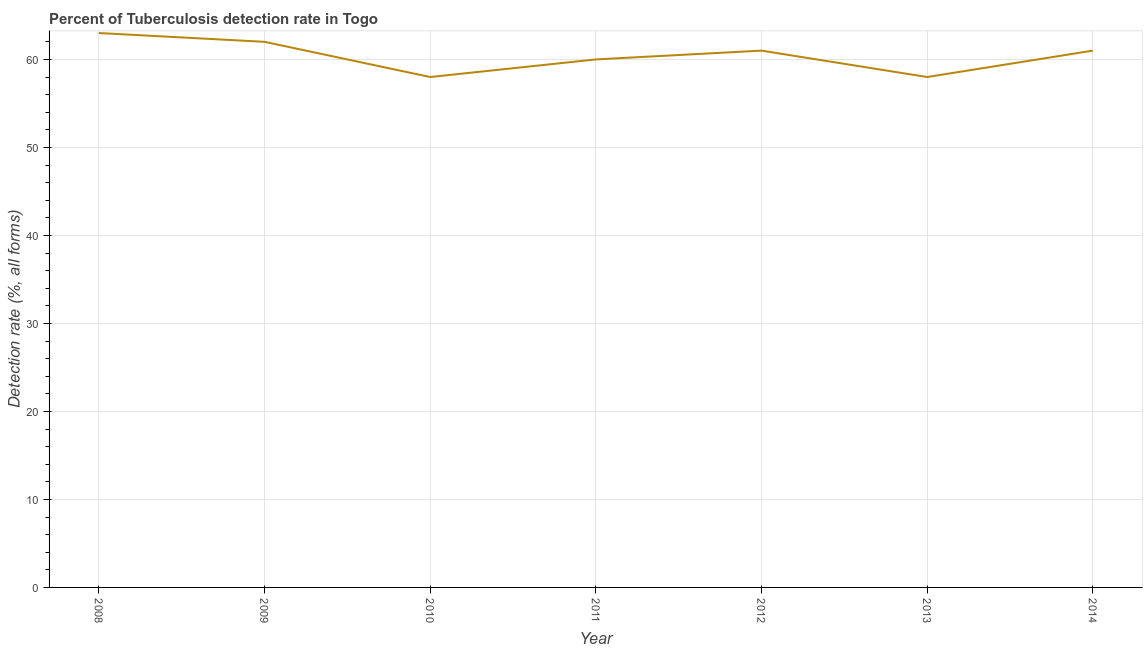What is the detection rate of tuberculosis in 2011?
Provide a succinct answer. 60. Across all years, what is the maximum detection rate of tuberculosis?
Offer a terse response. 63. Across all years, what is the minimum detection rate of tuberculosis?
Offer a very short reply. 58. In which year was the detection rate of tuberculosis maximum?
Give a very brief answer. 2008. What is the sum of the detection rate of tuberculosis?
Your answer should be very brief. 423. What is the difference between the detection rate of tuberculosis in 2011 and 2013?
Make the answer very short. 2. What is the average detection rate of tuberculosis per year?
Give a very brief answer. 60.43. What is the median detection rate of tuberculosis?
Your answer should be very brief. 61. What is the ratio of the detection rate of tuberculosis in 2009 to that in 2011?
Your answer should be compact. 1.03. Is the detection rate of tuberculosis in 2010 less than that in 2013?
Provide a short and direct response. No. Is the sum of the detection rate of tuberculosis in 2013 and 2014 greater than the maximum detection rate of tuberculosis across all years?
Your answer should be very brief. Yes. What is the difference between the highest and the lowest detection rate of tuberculosis?
Provide a short and direct response. 5. How many lines are there?
Your response must be concise. 1. What is the difference between two consecutive major ticks on the Y-axis?
Your answer should be compact. 10. Does the graph contain grids?
Keep it short and to the point. Yes. What is the title of the graph?
Ensure brevity in your answer.  Percent of Tuberculosis detection rate in Togo. What is the label or title of the Y-axis?
Offer a very short reply. Detection rate (%, all forms). What is the Detection rate (%, all forms) of 2008?
Give a very brief answer. 63. What is the Detection rate (%, all forms) in 2009?
Make the answer very short. 62. What is the Detection rate (%, all forms) in 2010?
Offer a terse response. 58. What is the Detection rate (%, all forms) in 2012?
Offer a very short reply. 61. What is the Detection rate (%, all forms) in 2014?
Provide a short and direct response. 61. What is the difference between the Detection rate (%, all forms) in 2008 and 2009?
Make the answer very short. 1. What is the difference between the Detection rate (%, all forms) in 2008 and 2011?
Your answer should be very brief. 3. What is the difference between the Detection rate (%, all forms) in 2008 and 2014?
Provide a short and direct response. 2. What is the difference between the Detection rate (%, all forms) in 2009 and 2010?
Keep it short and to the point. 4. What is the difference between the Detection rate (%, all forms) in 2009 and 2012?
Make the answer very short. 1. What is the difference between the Detection rate (%, all forms) in 2009 and 2013?
Provide a short and direct response. 4. What is the difference between the Detection rate (%, all forms) in 2009 and 2014?
Offer a very short reply. 1. What is the difference between the Detection rate (%, all forms) in 2010 and 2012?
Offer a very short reply. -3. What is the difference between the Detection rate (%, all forms) in 2010 and 2013?
Make the answer very short. 0. What is the difference between the Detection rate (%, all forms) in 2011 and 2013?
Make the answer very short. 2. What is the difference between the Detection rate (%, all forms) in 2012 and 2013?
Keep it short and to the point. 3. What is the difference between the Detection rate (%, all forms) in 2012 and 2014?
Ensure brevity in your answer.  0. What is the difference between the Detection rate (%, all forms) in 2013 and 2014?
Give a very brief answer. -3. What is the ratio of the Detection rate (%, all forms) in 2008 to that in 2010?
Keep it short and to the point. 1.09. What is the ratio of the Detection rate (%, all forms) in 2008 to that in 2011?
Offer a terse response. 1.05. What is the ratio of the Detection rate (%, all forms) in 2008 to that in 2012?
Give a very brief answer. 1.03. What is the ratio of the Detection rate (%, all forms) in 2008 to that in 2013?
Ensure brevity in your answer.  1.09. What is the ratio of the Detection rate (%, all forms) in 2008 to that in 2014?
Offer a very short reply. 1.03. What is the ratio of the Detection rate (%, all forms) in 2009 to that in 2010?
Keep it short and to the point. 1.07. What is the ratio of the Detection rate (%, all forms) in 2009 to that in 2011?
Keep it short and to the point. 1.03. What is the ratio of the Detection rate (%, all forms) in 2009 to that in 2013?
Offer a terse response. 1.07. What is the ratio of the Detection rate (%, all forms) in 2009 to that in 2014?
Provide a short and direct response. 1.02. What is the ratio of the Detection rate (%, all forms) in 2010 to that in 2012?
Offer a terse response. 0.95. What is the ratio of the Detection rate (%, all forms) in 2010 to that in 2014?
Ensure brevity in your answer.  0.95. What is the ratio of the Detection rate (%, all forms) in 2011 to that in 2013?
Give a very brief answer. 1.03. What is the ratio of the Detection rate (%, all forms) in 2012 to that in 2013?
Provide a short and direct response. 1.05. What is the ratio of the Detection rate (%, all forms) in 2012 to that in 2014?
Provide a succinct answer. 1. What is the ratio of the Detection rate (%, all forms) in 2013 to that in 2014?
Your response must be concise. 0.95. 